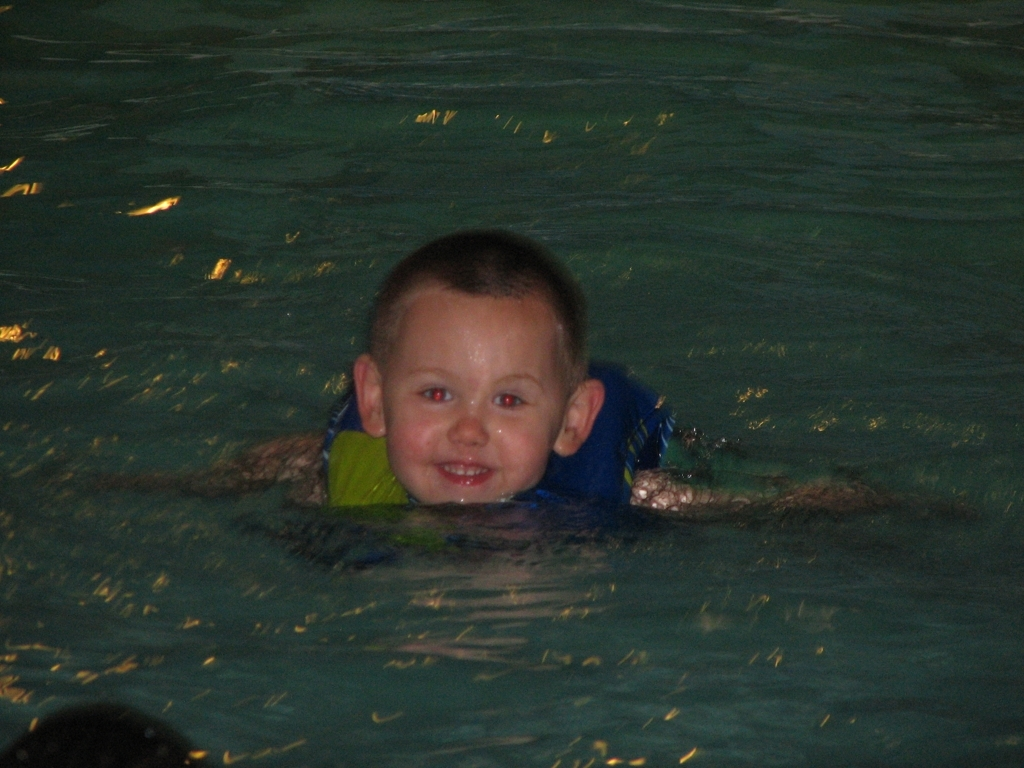Is the image blurry? The image is not blurry; it depicts a clear view of a child swimming with a floatation device, and the details are reasonably sharp and well-defined. 